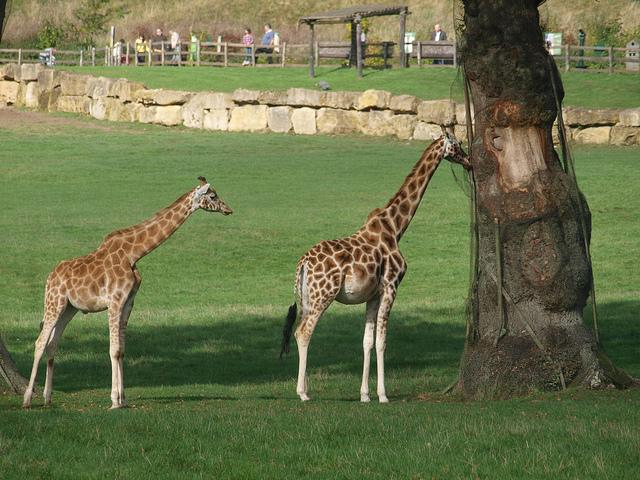What is there a giant hole taken out of the tree for? Please explain your reasoning. giraffes. Giraffes are grazing near a tree. 